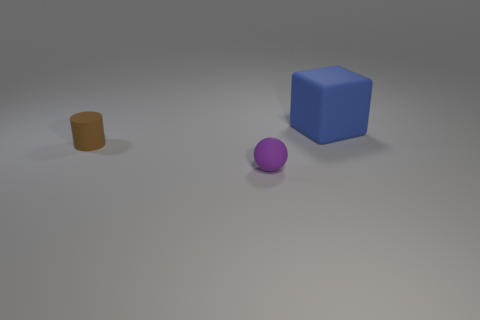Add 1 blocks. How many objects exist? 4 Add 2 small brown matte cylinders. How many small brown matte cylinders exist? 3 Subtract 0 green blocks. How many objects are left? 3 Subtract all balls. How many objects are left? 2 Subtract all brown rubber objects. Subtract all small purple rubber balls. How many objects are left? 1 Add 3 tiny purple rubber spheres. How many tiny purple rubber spheres are left? 4 